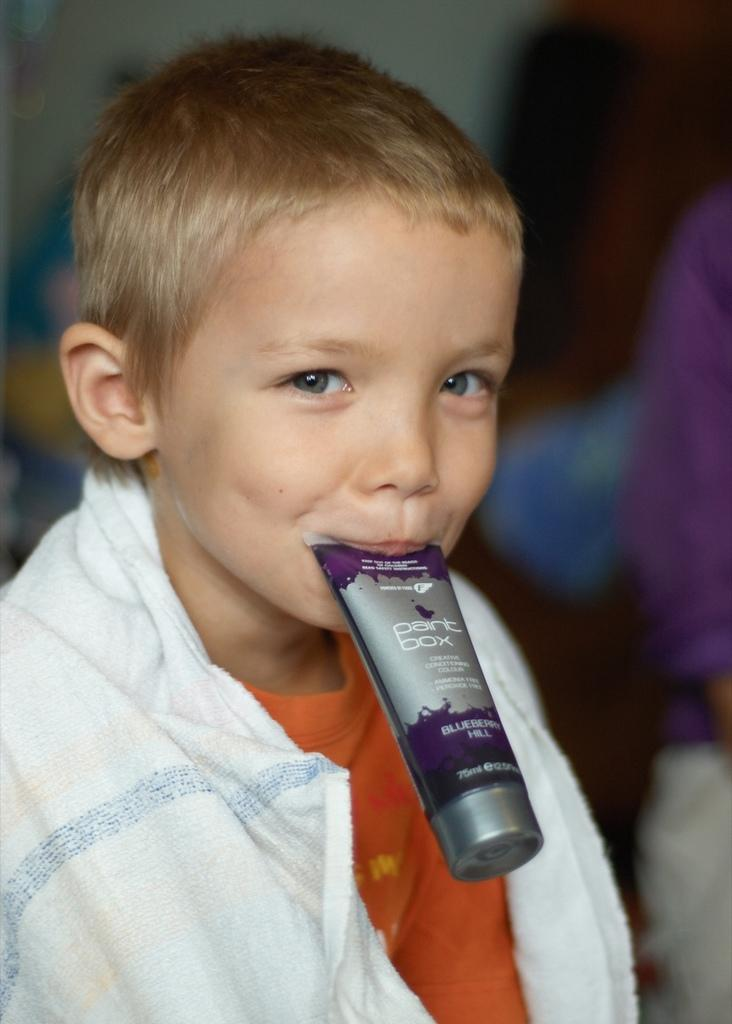What is the main subject of the image? There is a child in the image. What is the child doing in the image? The child has a pack of cream in his mouth. Are there any other people in the image? Yes, there is another person in the image. Can you describe the background of the image? The background of the image is blurry. What type of system is being used to grow crops in the image? There is no system for growing crops present in the image. Can you tell me how many ploughs are visible in the image? There are no ploughs visible in the image. 